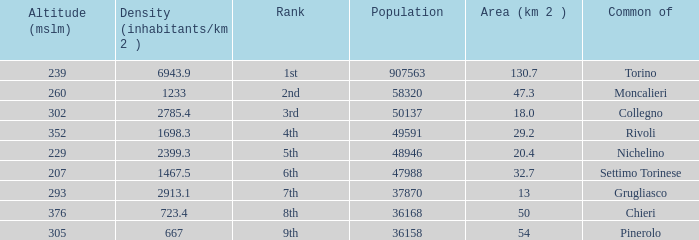The common of Chieri has what population density? 723.4. 